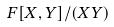Convert formula to latex. <formula><loc_0><loc_0><loc_500><loc_500>F [ X , Y ] / ( X Y )</formula> 